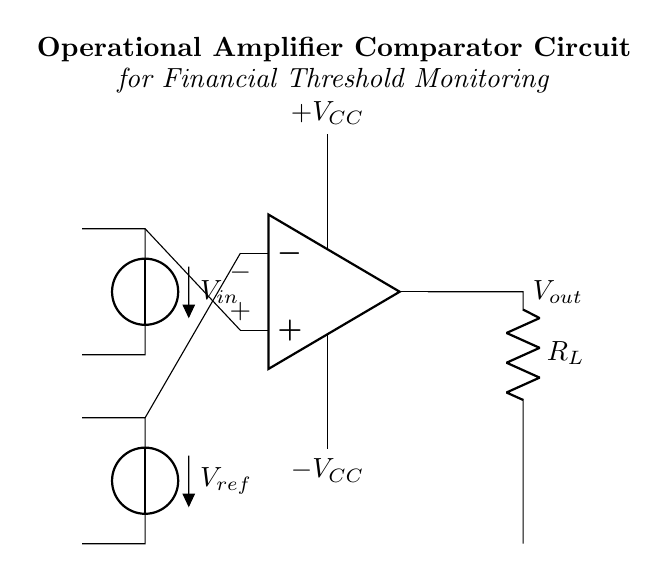What is the primary function of this circuit? The circuit functions as a comparator to monitor input voltage against a reference voltage. It compares the input voltage to a specified threshold and provides an output based on this comparison.
Answer: Comparator What are the supply voltages for the operational amplifier? The supplied voltages are indicated as +VCC and -VCC. These values provide the necessary power levels to ensure the operational amplifier works correctly, allowing it to amplify or compare the input signals.
Answer: +VCC and -VCC What does the symbol connected to the output represent? The symbol connected to the output is a resistor labeled R_L, which typically represents a load that the output signal will drive. It plays an important role in determining the output voltage level based on the current flowing through it.
Answer: R_L What occurs when the input voltage exceeds the reference voltage? When the input voltage exceeds the reference voltage, the output voltage will switch to a high state (close to +VCC), signaling that the threshold has been crossed. This indicates that the monitored condition requires attention or has been met.
Answer: Output goes high How do you determine the comparison condition in this circuit? The comparison condition is determined by observing the connections of the input voltage and reference voltage to the operational amplifier. If the voltage at the non-inverting input (+) is greater than the voltage at the inverting input (-), the output will indicate a high signal.
Answer: By comparing input and reference voltages What type of analysis is this circuit most likely used for? This circuit is primarily used for financial analysis, specifically monitoring threshold values that may affect financial decisions or indicators, such as profit margins or revenue thresholds.
Answer: Financial analysis 